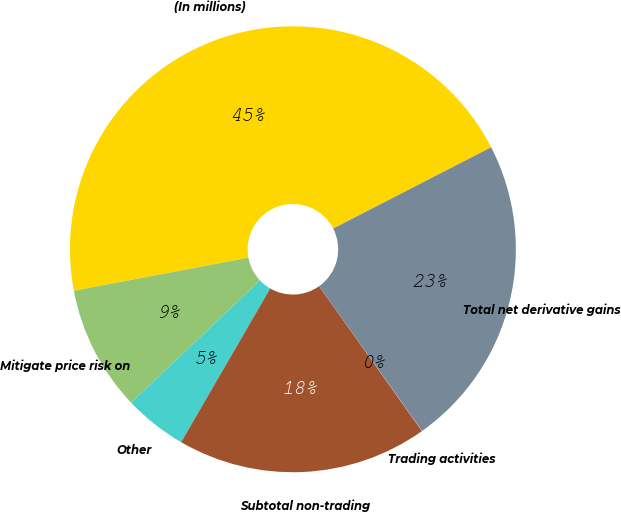Convert chart to OTSL. <chart><loc_0><loc_0><loc_500><loc_500><pie_chart><fcel>(In millions)<fcel>Mitigate price risk on<fcel>Other<fcel>Subtotal non-trading<fcel>Trading activities<fcel>Total net derivative gains<nl><fcel>45.42%<fcel>9.1%<fcel>4.56%<fcel>18.18%<fcel>0.02%<fcel>22.72%<nl></chart> 